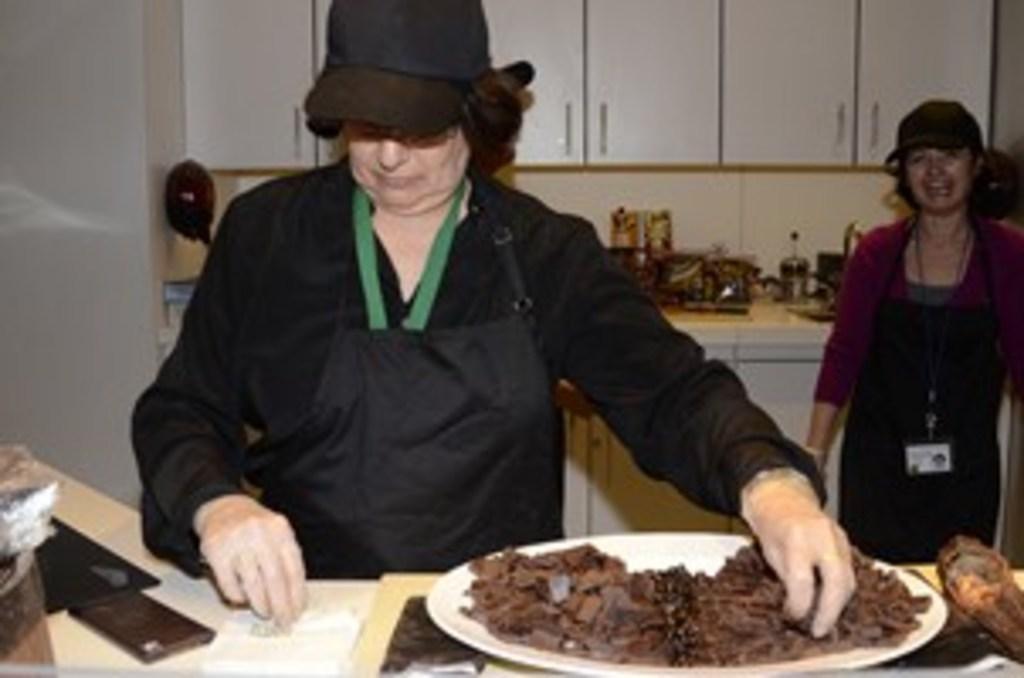Please provide a concise description of this image. This picture is clicked inside the room. In front, in middle of the picture, we see women wearing black dress is cooking or preparing something for food. We see, in front, we see table on which plate is placed and this plate contains some food and to the right corner of this picture, we see woman wearing purple shirt and she is even wearing cap and apron and also ID card and behind her, we see counter top on which vessels are placed and we can even see cup boards which are white in color. 